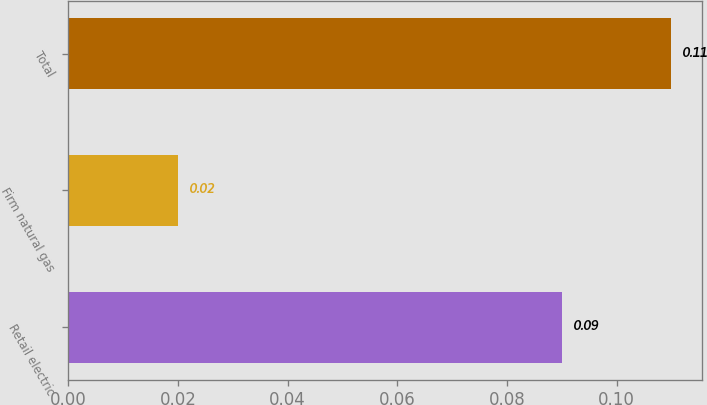Convert chart to OTSL. <chart><loc_0><loc_0><loc_500><loc_500><bar_chart><fcel>Retail electric<fcel>Firm natural gas<fcel>Total<nl><fcel>0.09<fcel>0.02<fcel>0.11<nl></chart> 